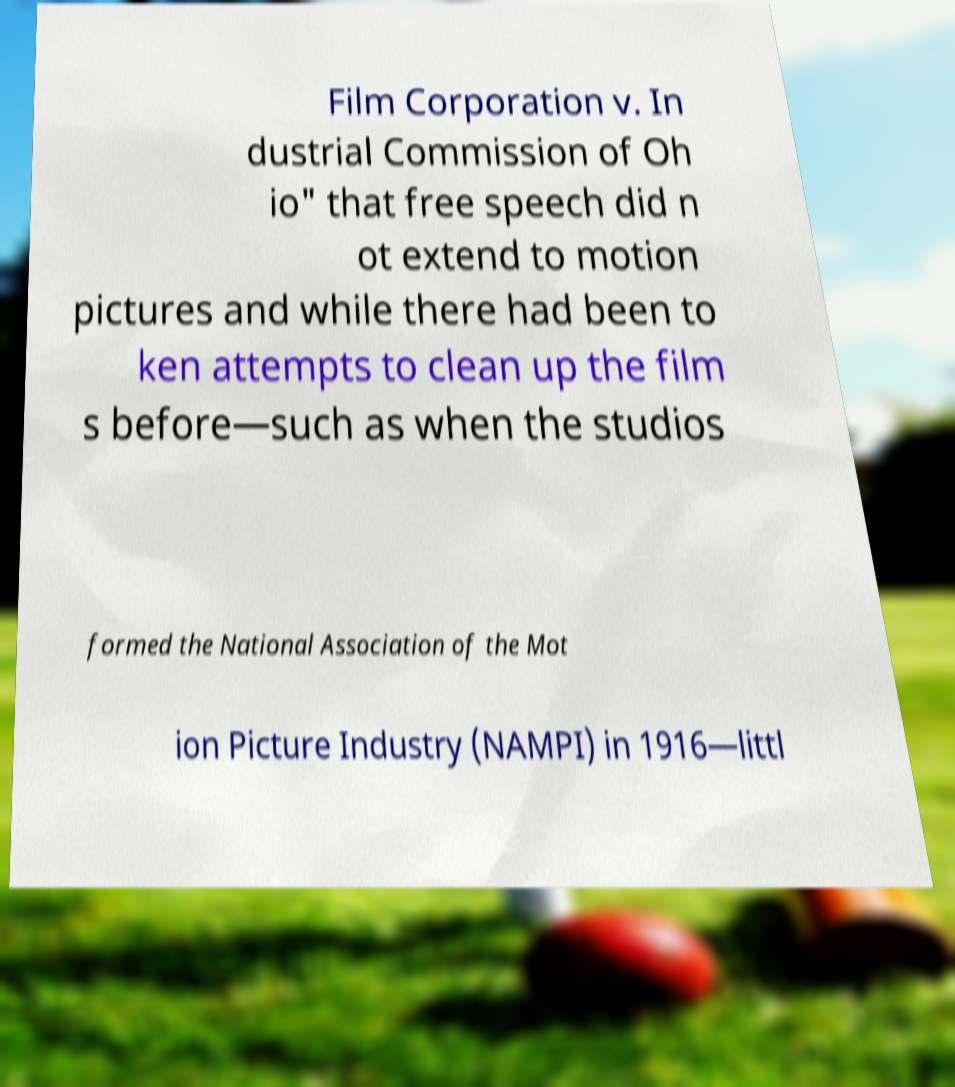What messages or text are displayed in this image? I need them in a readable, typed format. Film Corporation v. In dustrial Commission of Oh io" that free speech did n ot extend to motion pictures and while there had been to ken attempts to clean up the film s before—such as when the studios formed the National Association of the Mot ion Picture Industry (NAMPI) in 1916—littl 